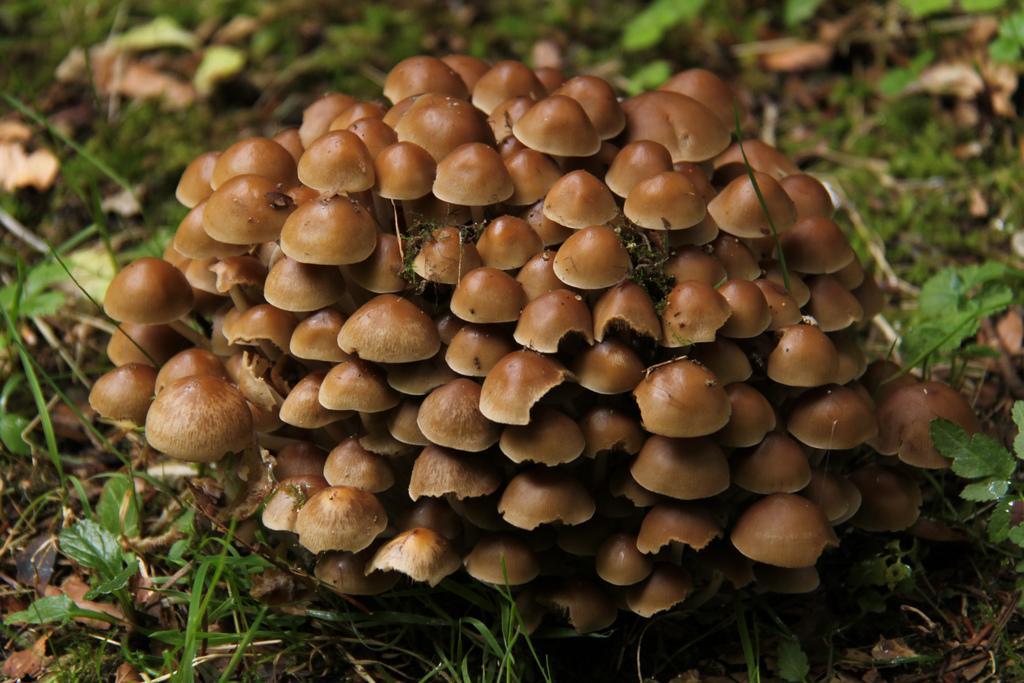Could you give a brief overview of what you see in this image? In this image I can see few mushrooms in brown color. In the background I can see few plants in green color. 